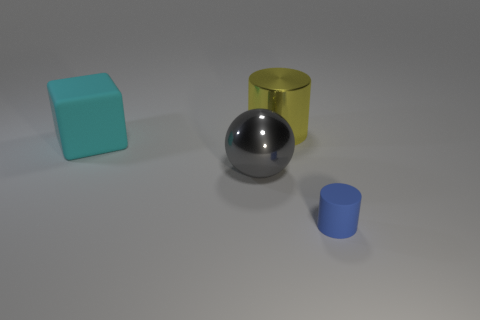How many objects are objects to the left of the large yellow cylinder or small blue cylinders?
Your response must be concise. 3. What is the color of the other thing that is the same shape as the big yellow metal thing?
Make the answer very short. Blue. There is a small object; is it the same shape as the yellow shiny thing on the right side of the gray sphere?
Your answer should be very brief. Yes. How many things are objects right of the large ball or metallic things that are to the left of the yellow cylinder?
Keep it short and to the point. 3. Is the number of matte things that are left of the big cylinder less than the number of large metallic things?
Ensure brevity in your answer.  Yes. Is the small cylinder made of the same material as the cylinder that is behind the big gray metallic object?
Provide a succinct answer. No. What is the material of the small object?
Your answer should be compact. Rubber. What is the material of the large thing that is in front of the big thing to the left of the metal object to the left of the big metal cylinder?
Your response must be concise. Metal. Is there any other thing that is the same shape as the large gray metal object?
Your answer should be very brief. No. There is a rubber thing behind the metal object to the left of the big yellow object; what color is it?
Keep it short and to the point. Cyan. 